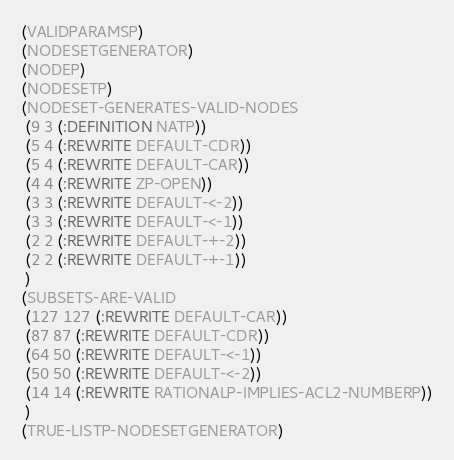Convert code to text. <code><loc_0><loc_0><loc_500><loc_500><_Lisp_>(VALIDPARAMSP)
(NODESETGENERATOR)
(NODEP)
(NODESETP)
(NODESET-GENERATES-VALID-NODES
 (9 3 (:DEFINITION NATP))
 (5 4 (:REWRITE DEFAULT-CDR))
 (5 4 (:REWRITE DEFAULT-CAR))
 (4 4 (:REWRITE ZP-OPEN))
 (3 3 (:REWRITE DEFAULT-<-2))
 (3 3 (:REWRITE DEFAULT-<-1))
 (2 2 (:REWRITE DEFAULT-+-2))
 (2 2 (:REWRITE DEFAULT-+-1))
 )
(SUBSETS-ARE-VALID
 (127 127 (:REWRITE DEFAULT-CAR))
 (87 87 (:REWRITE DEFAULT-CDR))
 (64 50 (:REWRITE DEFAULT-<-1))
 (50 50 (:REWRITE DEFAULT-<-2))
 (14 14 (:REWRITE RATIONALP-IMPLIES-ACL2-NUMBERP))
 )
(TRUE-LISTP-NODESETGENERATOR)
</code> 